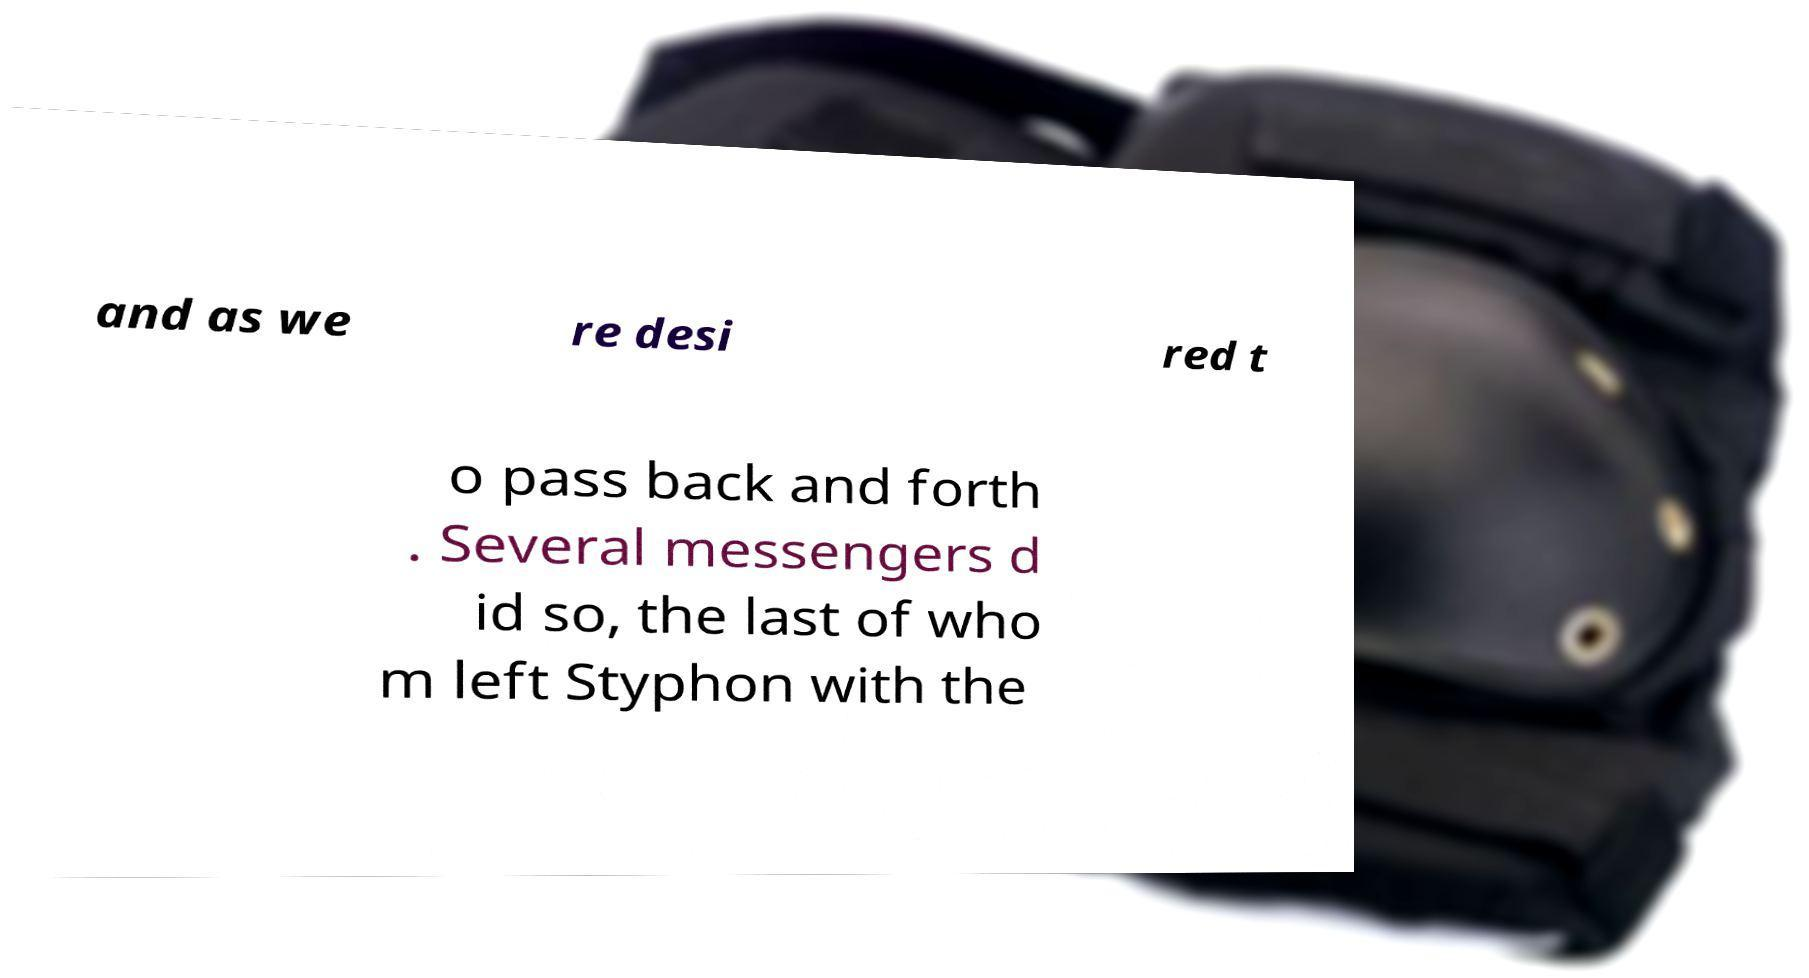Can you read and provide the text displayed in the image?This photo seems to have some interesting text. Can you extract and type it out for me? and as we re desi red t o pass back and forth . Several messengers d id so, the last of who m left Styphon with the 